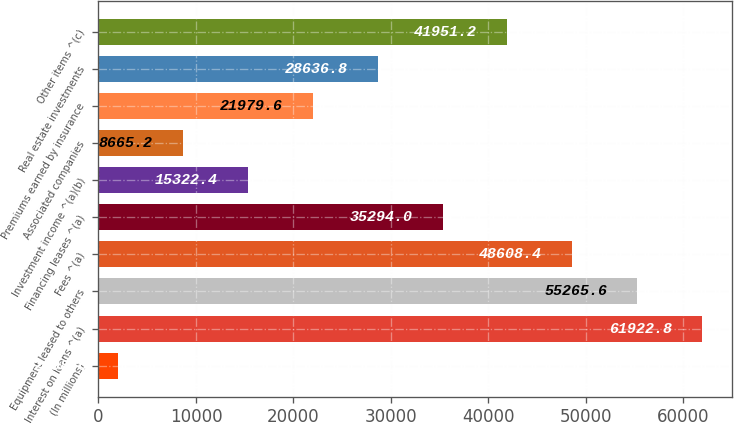Convert chart to OTSL. <chart><loc_0><loc_0><loc_500><loc_500><bar_chart><fcel>(In millions)<fcel>Interest on loans ^(a)<fcel>Equipment leased to others<fcel>Fees ^(a)<fcel>Financing leases ^(a)<fcel>Investment income ^(a)(b)<fcel>Associated companies<fcel>Premiums earned by insurance<fcel>Real estate investments<fcel>Other items ^(c)<nl><fcel>2008<fcel>61922.8<fcel>55265.6<fcel>48608.4<fcel>35294<fcel>15322.4<fcel>8665.2<fcel>21979.6<fcel>28636.8<fcel>41951.2<nl></chart> 